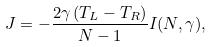Convert formula to latex. <formula><loc_0><loc_0><loc_500><loc_500>J = - \frac { 2 \gamma \, ( T _ { L } - T _ { R } ) } { N - 1 } I ( N , \gamma ) ,</formula> 